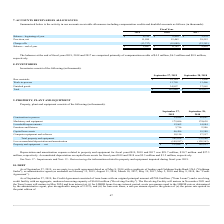From Macom Technology's financial document, What were the respective balances at the end of 2019, 2018 and 2017? The document contains multiple relevant values: $4.5 million, $6.3 million, $8.9 million. From the document: "are comprised primarily of compensation credits of $4.5 million, $6.3 million and $8.9 million, ensation credits of $4.5 million, $6.3 million and $8...." Also, What was the respective value of Provision, net in 2019 and 2018? The document shows two values: 11,989 and 15,465 (in thousands). From the document: "Provision, net 11,989 15,465 29,512 Provision, net 11,989 15,465 29,512..." Also, What was the charge-offs in 2019? According to the financial document, (13,737) (in thousands). The relevant text states: "Charge-offs (13,737) (18,080) (23,381)..." Also, can you calculate: What was the change in the Balance - beginning of year from 2018 to 2019? Based on the calculation: 6,795 - 9,410, the result is -2615 (in thousands). This is based on the information: "Balance - beginning of year $ 6,795 $ 9,410 $ 3,279 Balance - beginning of year $ 6,795 $ 9,410 $ 3,279..." The key data points involved are: 6,795, 9,410. Also, can you calculate: What was the average Provision, net for 2017-2019? To answer this question, I need to perform calculations using the financial data. The calculation is: (11,989 + 15,465 + 29,512) / 3, which equals 18988.67 (in thousands). This is based on the information: "Provision, net 11,989 15,465 29,512 Provision, net 11,989 15,465 29,512 Provision, net 11,989 15,465 29,512..." The key data points involved are: 11,989, 15,465, 29,512. Additionally, In which year was Balance - end of year less than 7,000 thousands? The document shows two values: 2019 and 2018. Locate and analyze balance - end of year in row 6. From the document: "2019 2018 2017 2019 2018 2017..." 